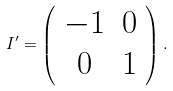<formula> <loc_0><loc_0><loc_500><loc_500>I ^ { \prime } = \left ( \begin{array} { c c } - 1 & 0 \\ 0 & 1 \end{array} \right ) .</formula> 